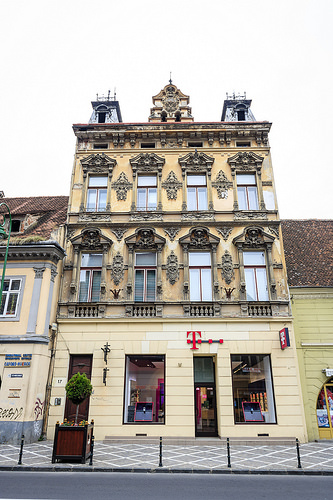<image>
Is the tower above the roof? Yes. The tower is positioned above the roof in the vertical space, higher up in the scene. 